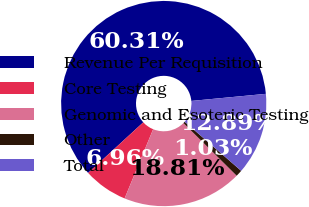<chart> <loc_0><loc_0><loc_500><loc_500><pie_chart><fcel>Revenue Per Requisition<fcel>Core Testing<fcel>Genomic and Esoteric Testing<fcel>Other<fcel>Total<nl><fcel>60.3%<fcel>6.96%<fcel>18.81%<fcel>1.03%<fcel>12.89%<nl></chart> 